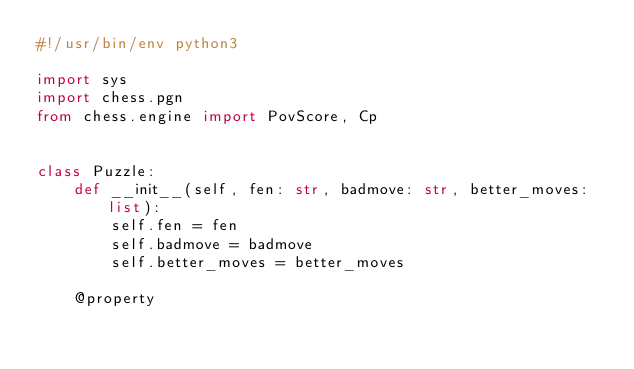<code> <loc_0><loc_0><loc_500><loc_500><_Python_>#!/usr/bin/env python3

import sys
import chess.pgn
from chess.engine import PovScore, Cp


class Puzzle:
    def __init__(self, fen: str, badmove: str, better_moves: list):
        self.fen = fen
        self.badmove = badmove
        self.better_moves = better_moves

    @property</code> 